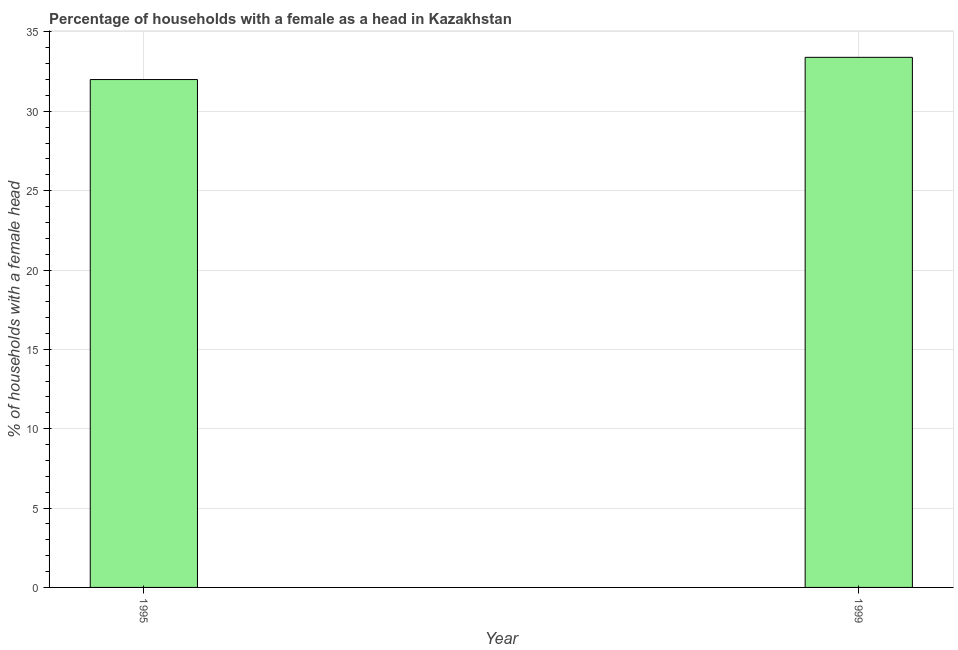Does the graph contain any zero values?
Offer a terse response. No. Does the graph contain grids?
Keep it short and to the point. Yes. What is the title of the graph?
Give a very brief answer. Percentage of households with a female as a head in Kazakhstan. What is the label or title of the Y-axis?
Give a very brief answer. % of households with a female head. What is the number of female supervised households in 1999?
Make the answer very short. 33.4. Across all years, what is the maximum number of female supervised households?
Your answer should be compact. 33.4. Across all years, what is the minimum number of female supervised households?
Your answer should be compact. 32. In which year was the number of female supervised households maximum?
Give a very brief answer. 1999. In which year was the number of female supervised households minimum?
Keep it short and to the point. 1995. What is the sum of the number of female supervised households?
Your answer should be compact. 65.4. What is the difference between the number of female supervised households in 1995 and 1999?
Provide a short and direct response. -1.4. What is the average number of female supervised households per year?
Your answer should be very brief. 32.7. What is the median number of female supervised households?
Ensure brevity in your answer.  32.7. In how many years, is the number of female supervised households greater than 18 %?
Make the answer very short. 2. Do a majority of the years between 1999 and 1995 (inclusive) have number of female supervised households greater than 5 %?
Make the answer very short. No. What is the ratio of the number of female supervised households in 1995 to that in 1999?
Keep it short and to the point. 0.96. Is the number of female supervised households in 1995 less than that in 1999?
Offer a very short reply. Yes. In how many years, is the number of female supervised households greater than the average number of female supervised households taken over all years?
Give a very brief answer. 1. How many bars are there?
Provide a succinct answer. 2. How many years are there in the graph?
Keep it short and to the point. 2. What is the difference between two consecutive major ticks on the Y-axis?
Ensure brevity in your answer.  5. What is the % of households with a female head of 1999?
Offer a very short reply. 33.4. What is the ratio of the % of households with a female head in 1995 to that in 1999?
Offer a very short reply. 0.96. 